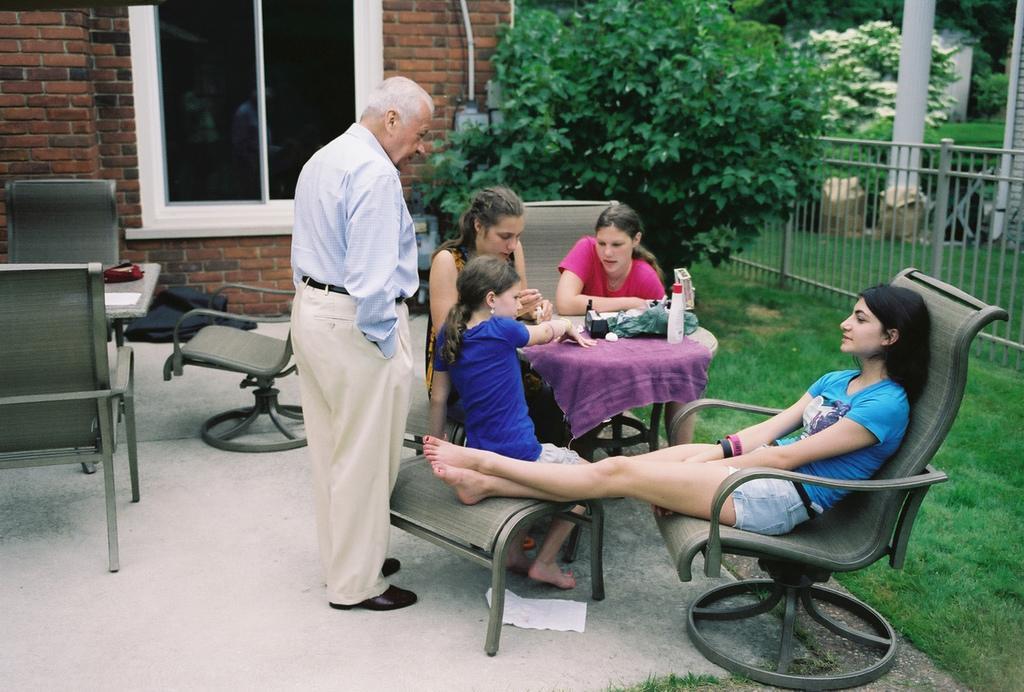Describe this image in one or two sentences. This is a picture taken in the outdoors. It is sunny. There are group of people sitting on a chair and the man is standing on the floor in front of this people there is a table on the table there are some items. Background of this people is trees and building. 